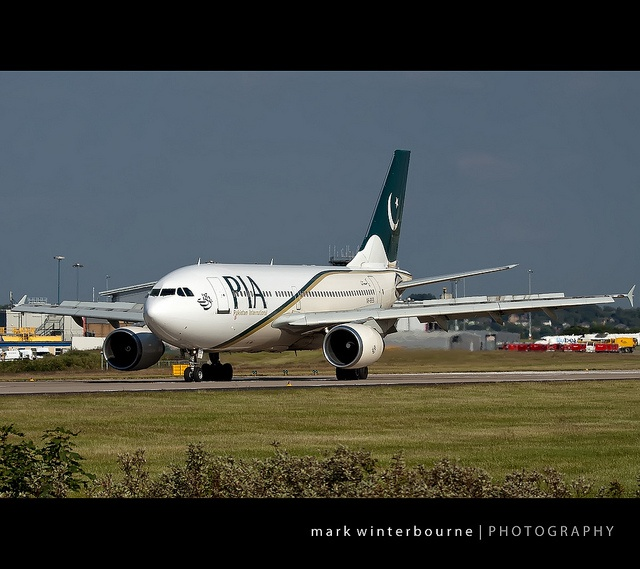Describe the objects in this image and their specific colors. I can see airplane in black, lightgray, darkgray, and gray tones, airplane in black, white, darkgray, gray, and lightblue tones, truck in black, orange, olive, and gray tones, truck in black, maroon, gray, white, and brown tones, and truck in black, lightgray, darkgray, and gray tones in this image. 